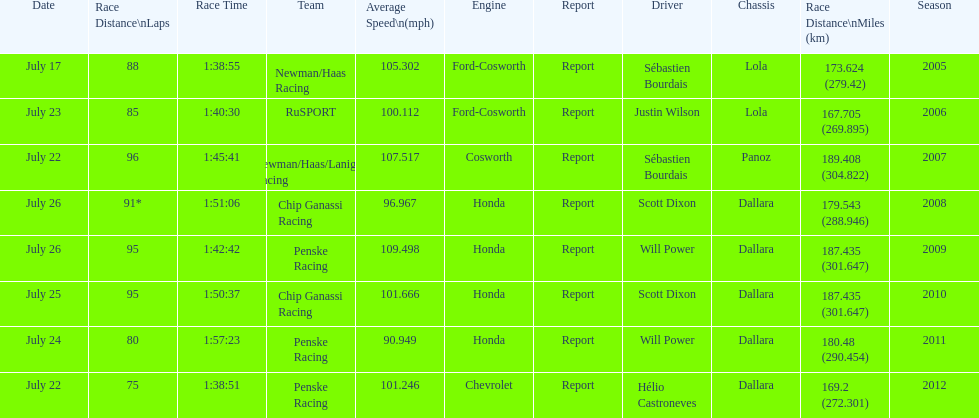How many different teams are represented in the table? 4. 